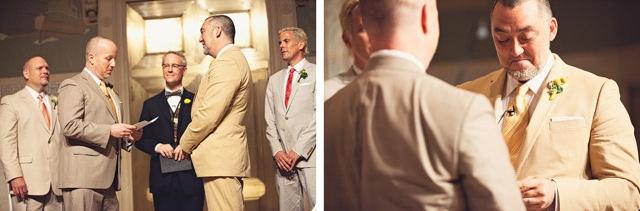Is everyone happy?
Give a very brief answer. Yes. Is this a business meeting?
Quick response, please. No. Does this look like a gay marriage?
Quick response, please. Yes. 